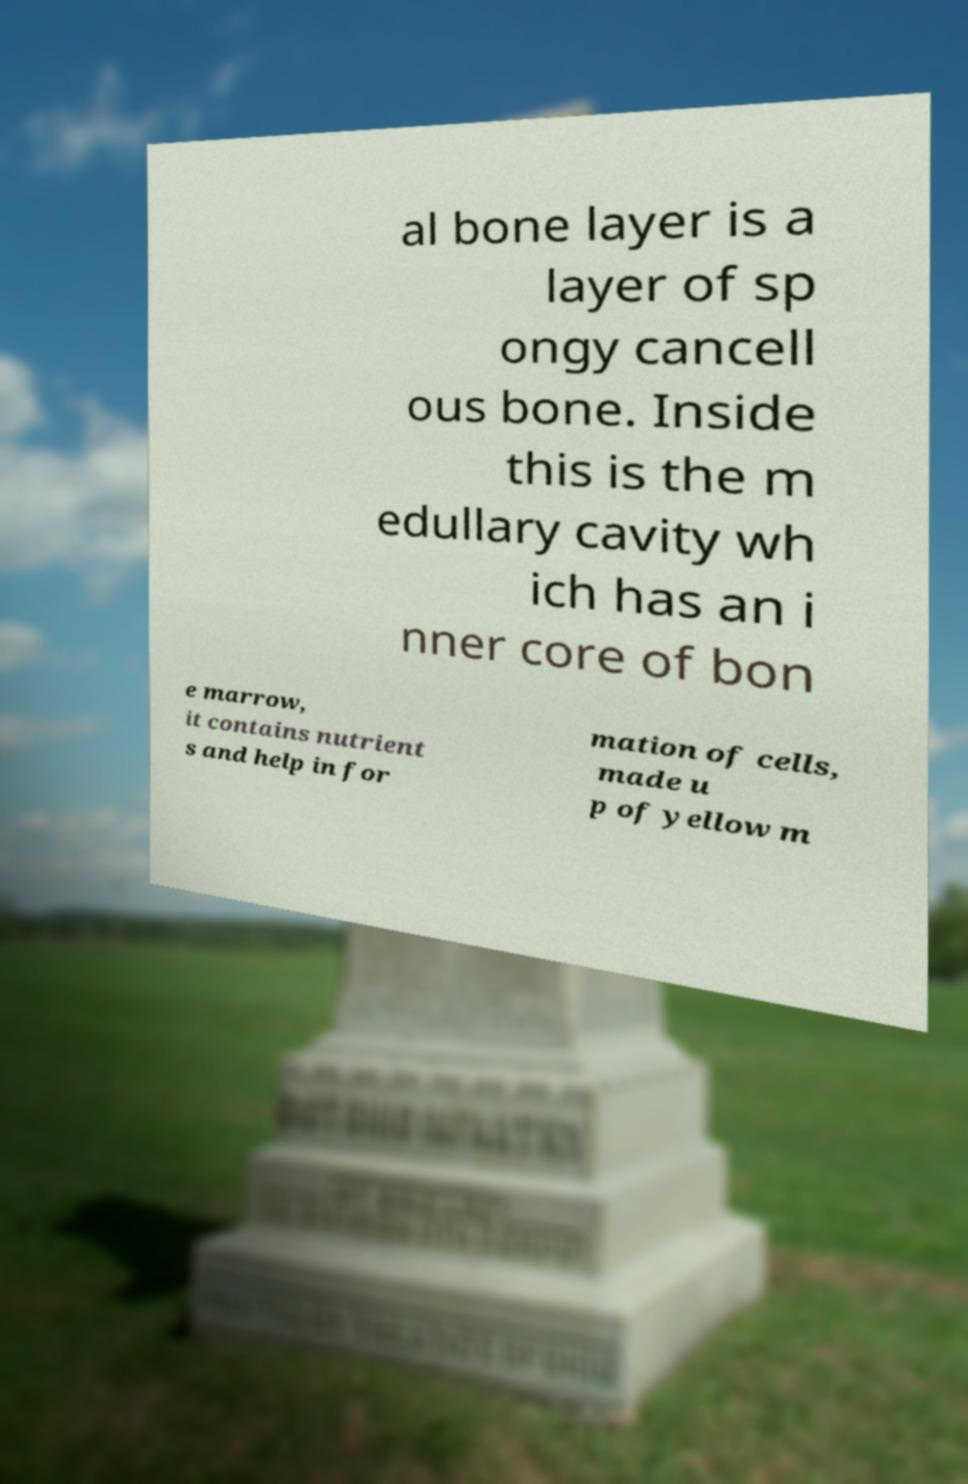Can you accurately transcribe the text from the provided image for me? al bone layer is a layer of sp ongy cancell ous bone. Inside this is the m edullary cavity wh ich has an i nner core of bon e marrow, it contains nutrient s and help in for mation of cells, made u p of yellow m 